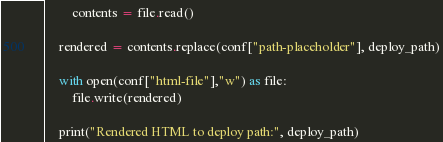<code> <loc_0><loc_0><loc_500><loc_500><_Python_>        contents = file.read()

    rendered = contents.replace(conf["path-placeholder"], deploy_path)

    with open(conf["html-file"],"w") as file:
        file.write(rendered)

    print("Rendered HTML to deploy path:", deploy_path)
</code> 